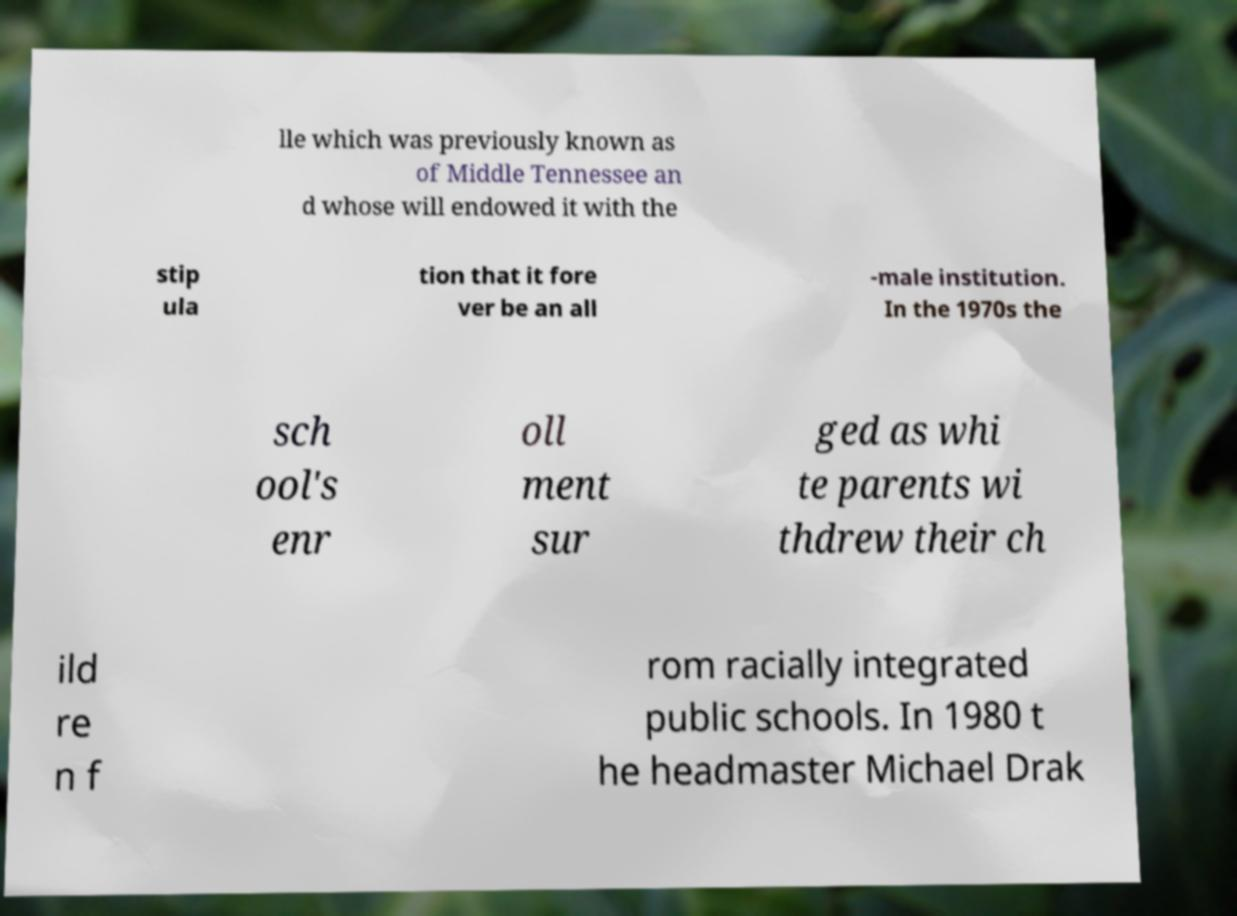Please read and relay the text visible in this image. What does it say? lle which was previously known as of Middle Tennessee an d whose will endowed it with the stip ula tion that it fore ver be an all -male institution. In the 1970s the sch ool's enr oll ment sur ged as whi te parents wi thdrew their ch ild re n f rom racially integrated public schools. In 1980 t he headmaster Michael Drak 